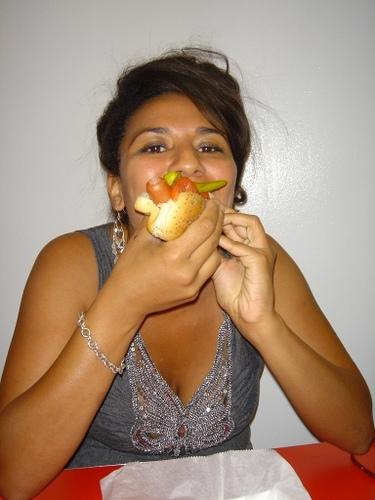What jewelry is the woman wearing?
Be succinct. Bracelet. Is this a woman?
Answer briefly. Yes. Are there any vegetables on this woman's hotdog?
Concise answer only. Yes. 